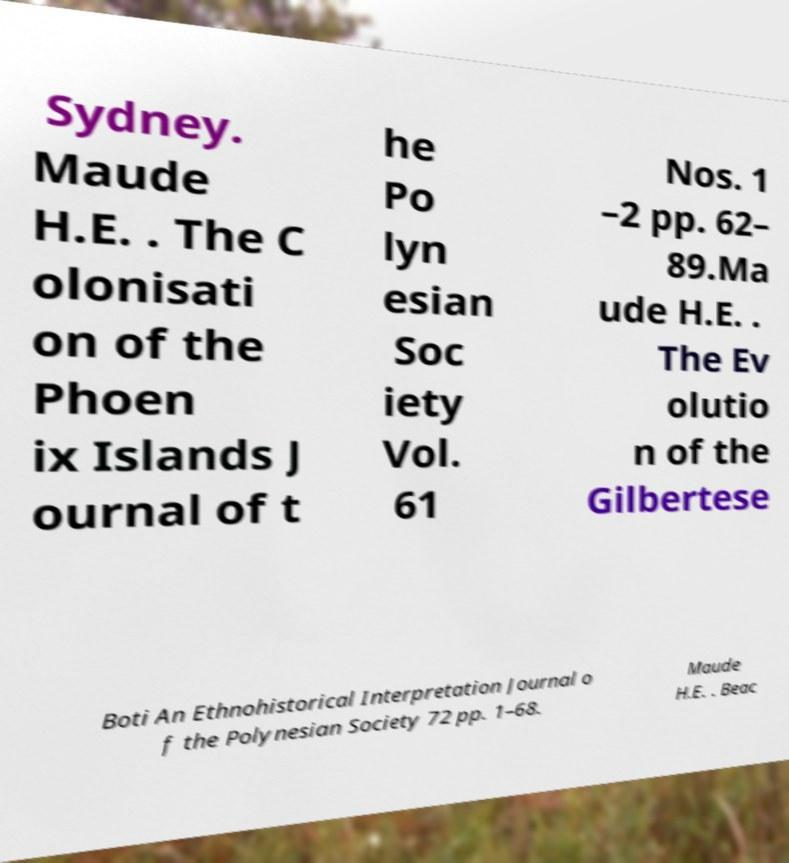Can you read and provide the text displayed in the image?This photo seems to have some interesting text. Can you extract and type it out for me? Sydney. Maude H.E. . The C olonisati on of the Phoen ix Islands J ournal of t he Po lyn esian Soc iety Vol. 61 Nos. 1 –2 pp. 62– 89.Ma ude H.E. . The Ev olutio n of the Gilbertese Boti An Ethnohistorical Interpretation Journal o f the Polynesian Society 72 pp. 1–68. Maude H.E. . Beac 